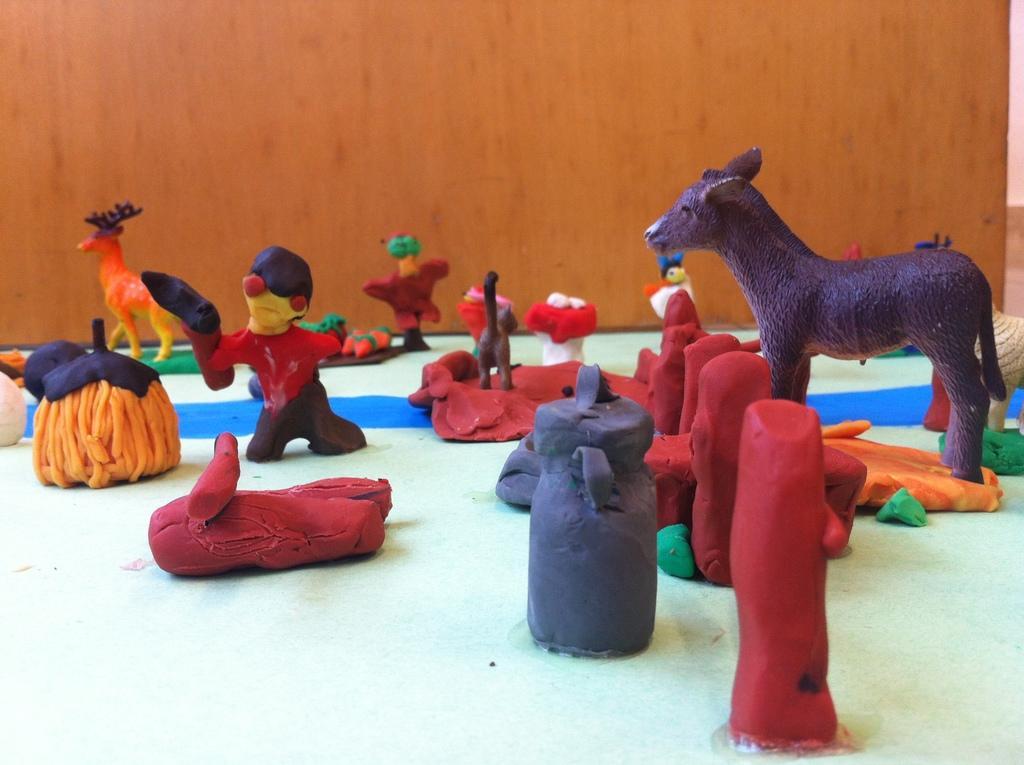Please provide a concise description of this image. In the image in the center, we can see few colorful toys like animals, poles, cans etc, which is made up of clay. In the background there is a wall. 